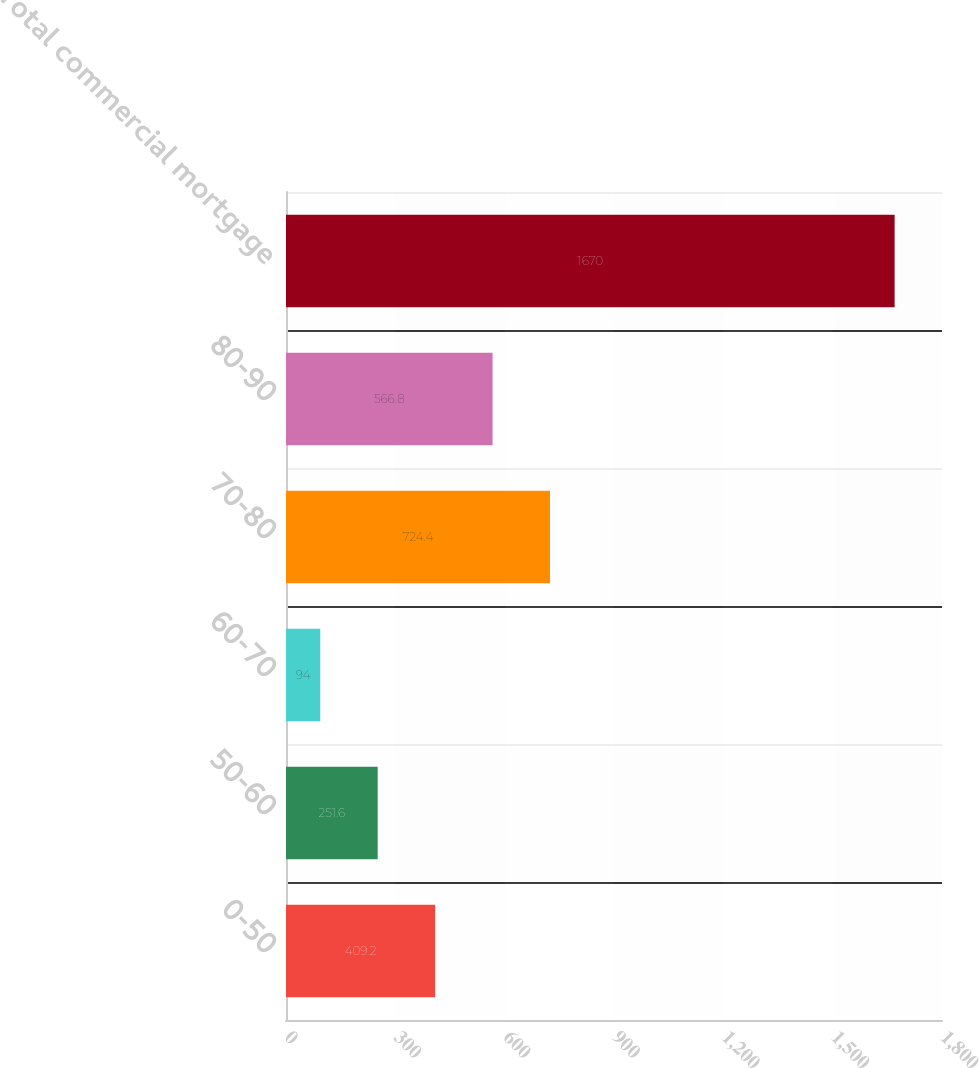Convert chart to OTSL. <chart><loc_0><loc_0><loc_500><loc_500><bar_chart><fcel>0-50<fcel>50-60<fcel>60-70<fcel>70-80<fcel>80-90<fcel>Total commercial mortgage<nl><fcel>409.2<fcel>251.6<fcel>94<fcel>724.4<fcel>566.8<fcel>1670<nl></chart> 